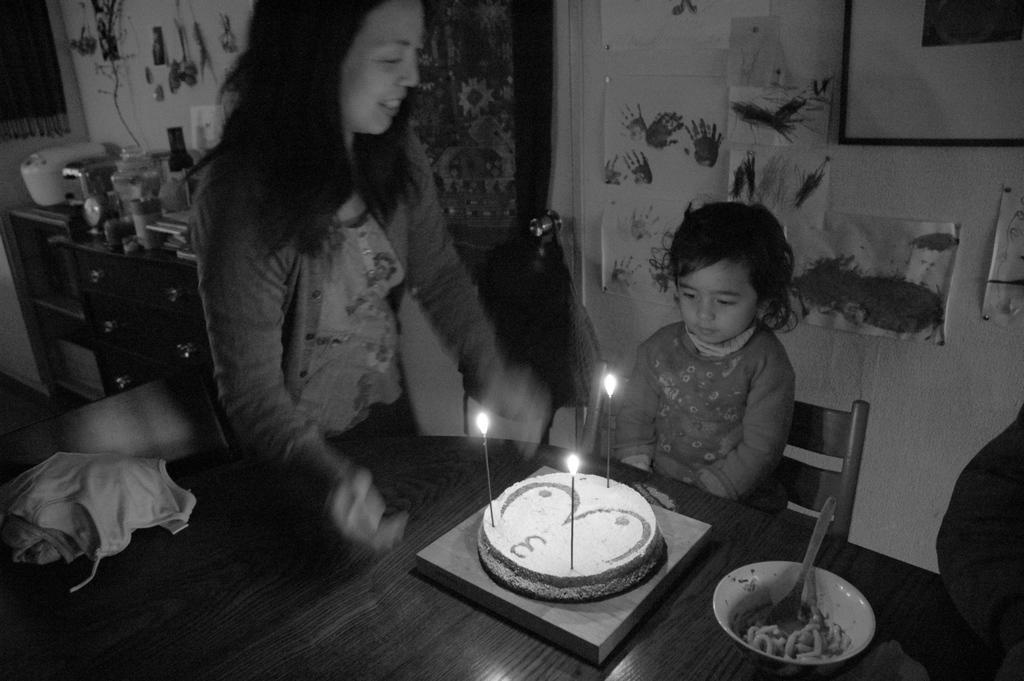Describe this image in one or two sentences. This is a black and white image. At the bottom of the image there is a table. On the table there is a cloth, cake with candles, bowl with food items and a spoon in it. Behind the table there is a kid sitting on the chair. Beside the kid there is a lady standing. And on the right corner of the image on the table there is a hand. In the background there is a wall with painted papers. And on the left corner of the image there is a cupboard with few items on it. And also there are few things hanging on the wall. 